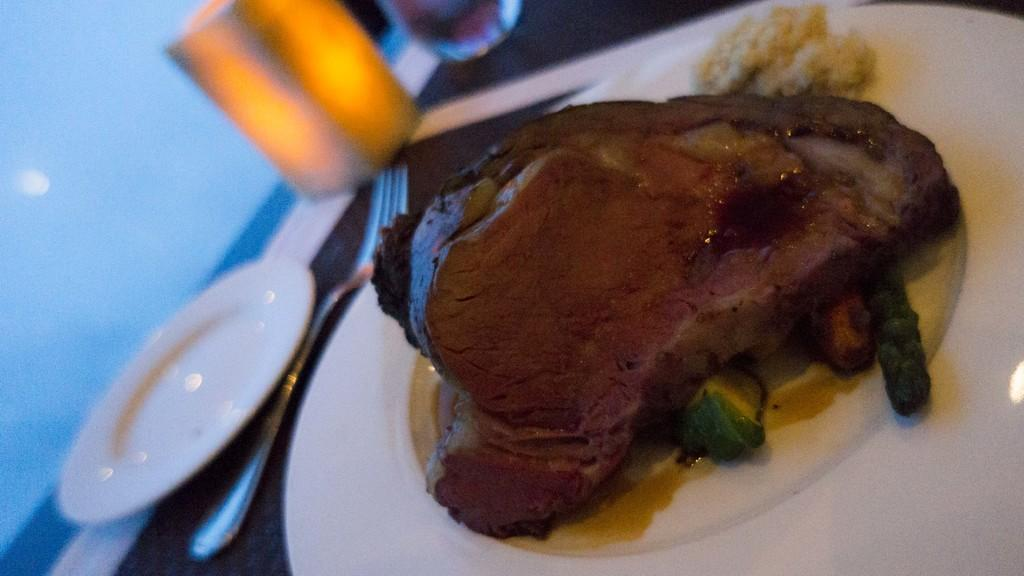What type of tableware can be seen in the image? There are plates and forks in the image. What else is present in the image besides tableware? There is food in the image. Can you describe the unspecified object in the image? Unfortunately, the facts provided do not give any details about the unspecified object. What type of road can be seen in the image? There is no road present in the image. Is there a stove visible in the image? There is no stove present in the image. 